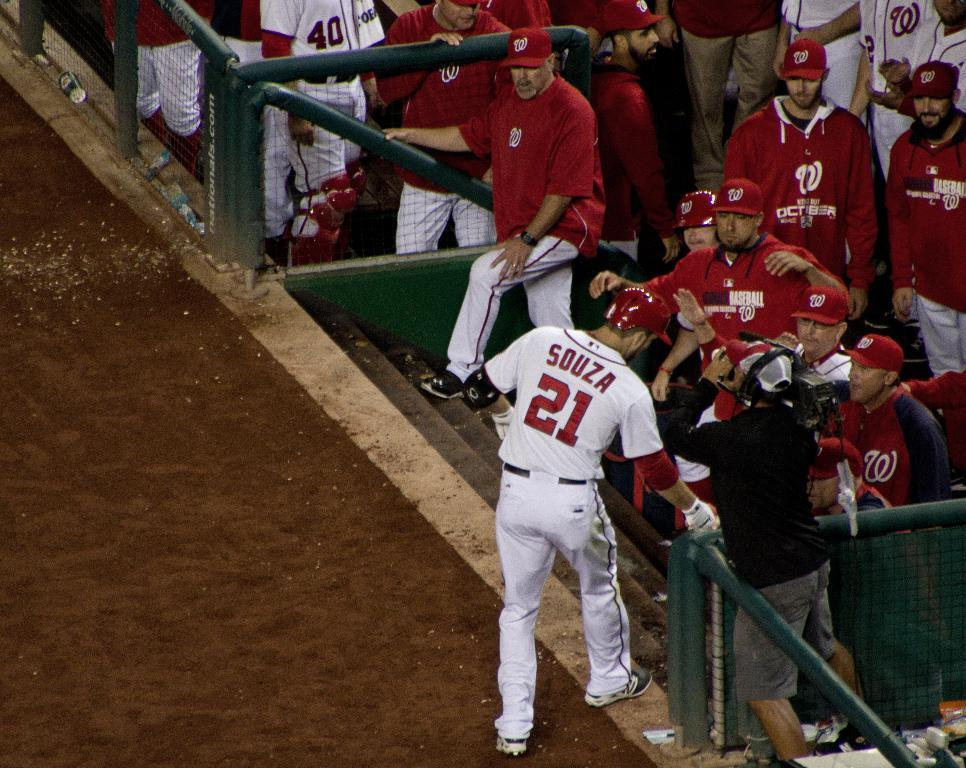Provide a one-sentence caption for the provided image. A baseball player named Souza approaches the dugout. 